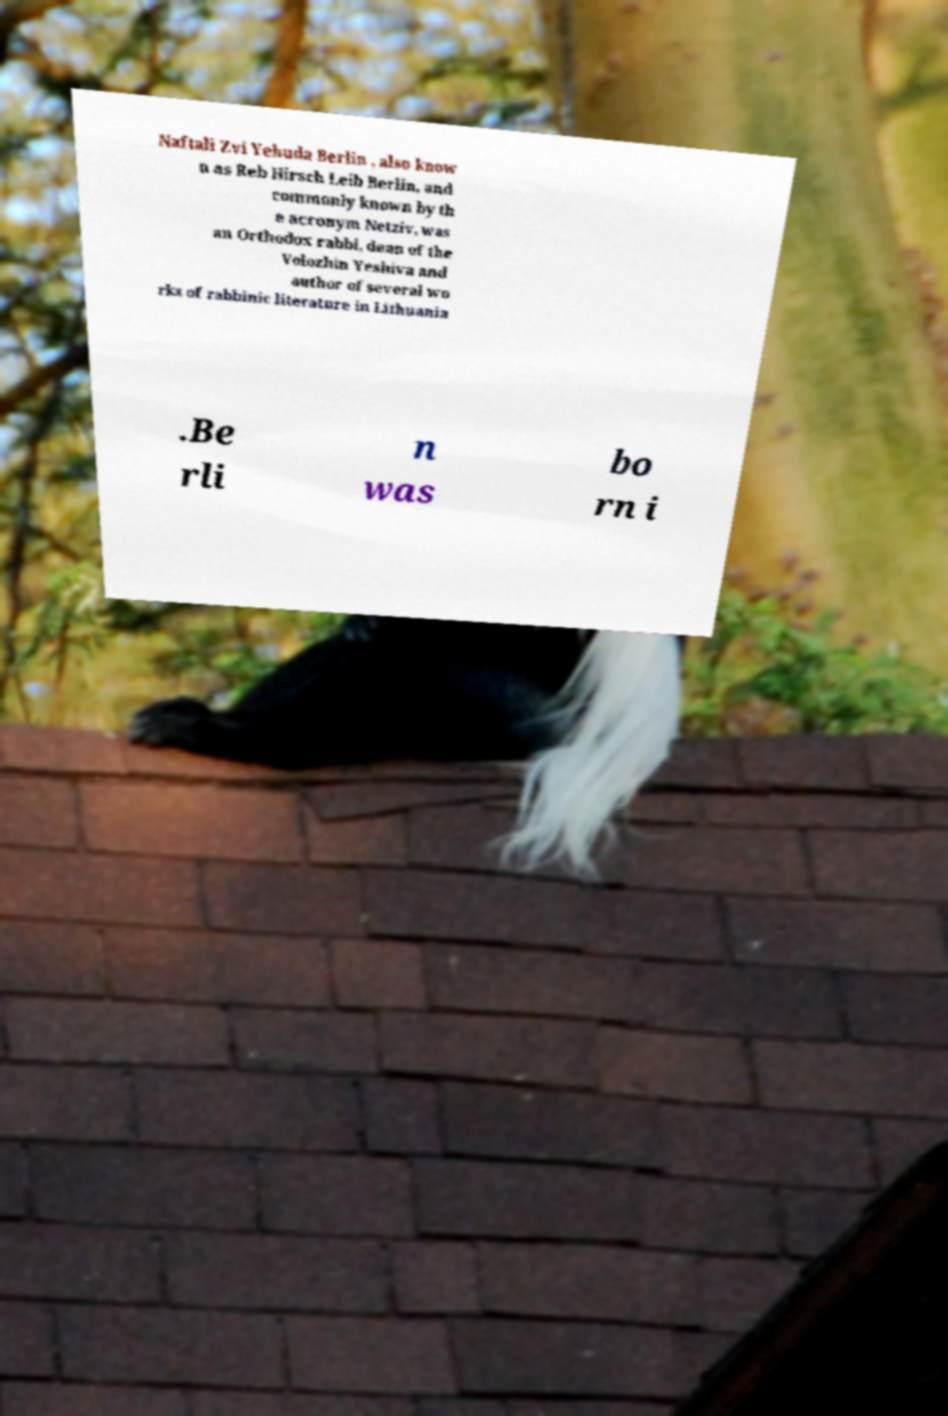Can you accurately transcribe the text from the provided image for me? Naftali Zvi Yehuda Berlin , also know n as Reb Hirsch Leib Berlin, and commonly known by th e acronym Netziv, was an Orthodox rabbi, dean of the Volozhin Yeshiva and author of several wo rks of rabbinic literature in Lithuania .Be rli n was bo rn i 